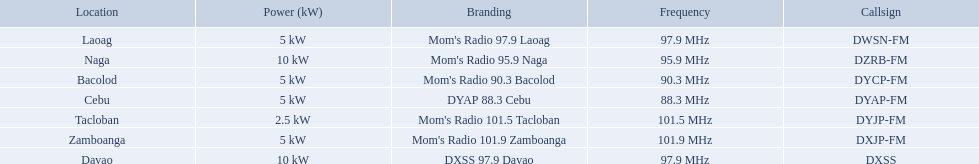Which stations use less than 10kw of power? Mom's Radio 97.9 Laoag, Mom's Radio 90.3 Bacolod, DYAP 88.3 Cebu, Mom's Radio 101.5 Tacloban, Mom's Radio 101.9 Zamboanga. Do any stations use less than 5kw of power? if so, which ones? Mom's Radio 101.5 Tacloban. 